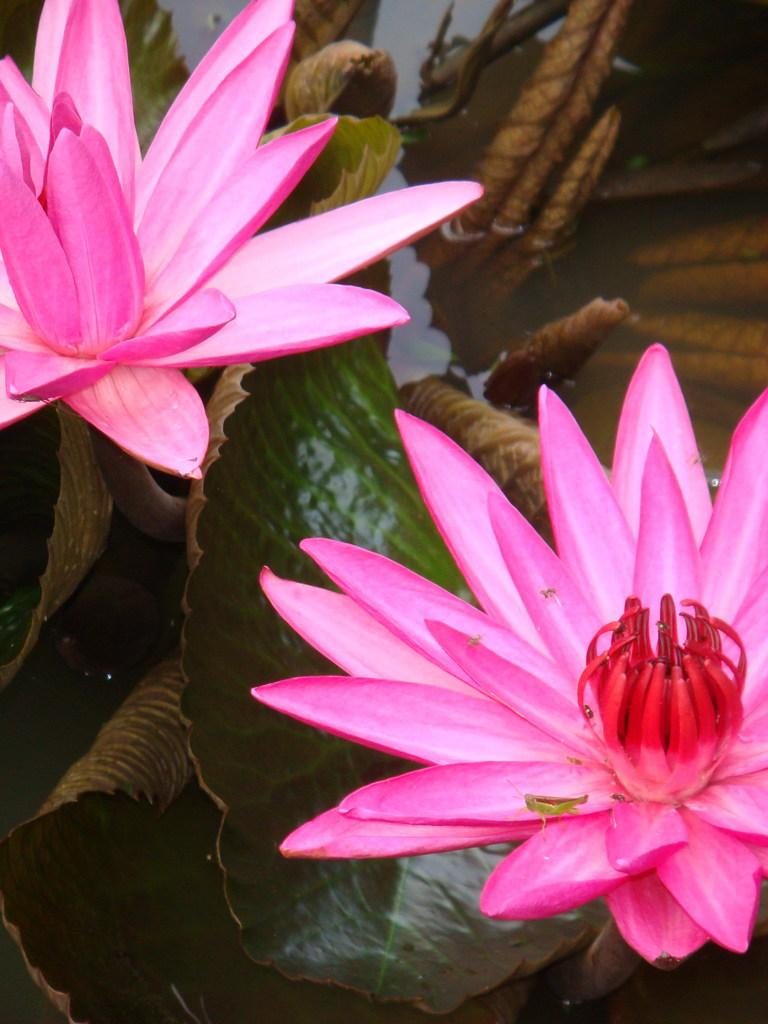What type of flowers are in the image? There are lotus flowers in the image. Where are the lotus flowers located? The lotus flowers are in a pond. What point is the cart making in the image? There is no cart present in the image, so it cannot make any points. 